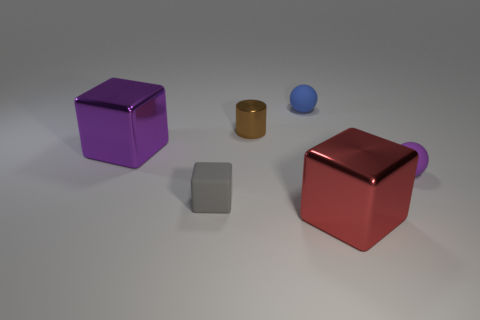Is there any other thing that has the same shape as the small brown metal thing?
Provide a succinct answer. No. Does the big metal block that is in front of the small purple matte thing have the same color as the tiny sphere behind the tiny shiny object?
Offer a terse response. No. There is a cube that is right of the purple metal thing and left of the red metallic block; what material is it made of?
Provide a succinct answer. Rubber. Is there a yellow object?
Offer a terse response. No. What shape is the small object that is made of the same material as the large red thing?
Keep it short and to the point. Cylinder. There is a small purple rubber object; is its shape the same as the large thing left of the small rubber block?
Ensure brevity in your answer.  No. What is the material of the big cube on the left side of the matte thing on the left side of the tiny cylinder?
Your answer should be compact. Metal. What number of other things are there of the same shape as the tiny purple rubber object?
Make the answer very short. 1. There is a large metal thing that is on the left side of the tiny gray cube; does it have the same shape as the large metallic object to the right of the tiny blue object?
Your response must be concise. Yes. What material is the small purple object?
Provide a short and direct response. Rubber. 